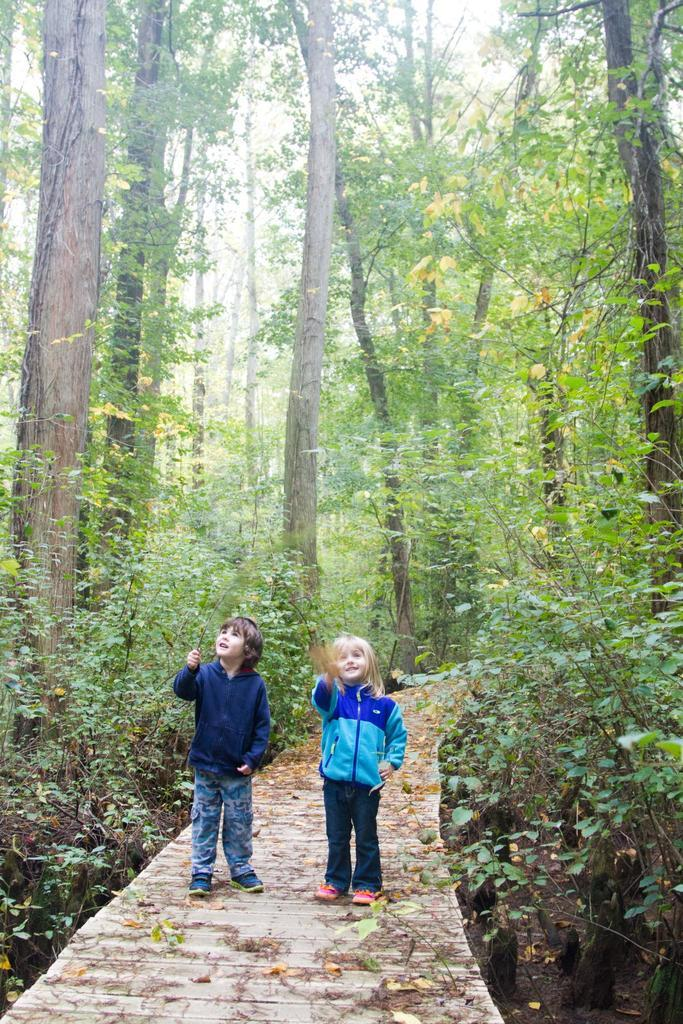What are the two main subjects in the image? There is a boy and a girl in the image. What are the boy and the girl doing in the image? Both the boy and the girl are standing. What can be seen in the background of the image? There are trees visible in the background of the image. What type of noise can be heard coming from the hand in the image? There is no hand or noise present in the image. 